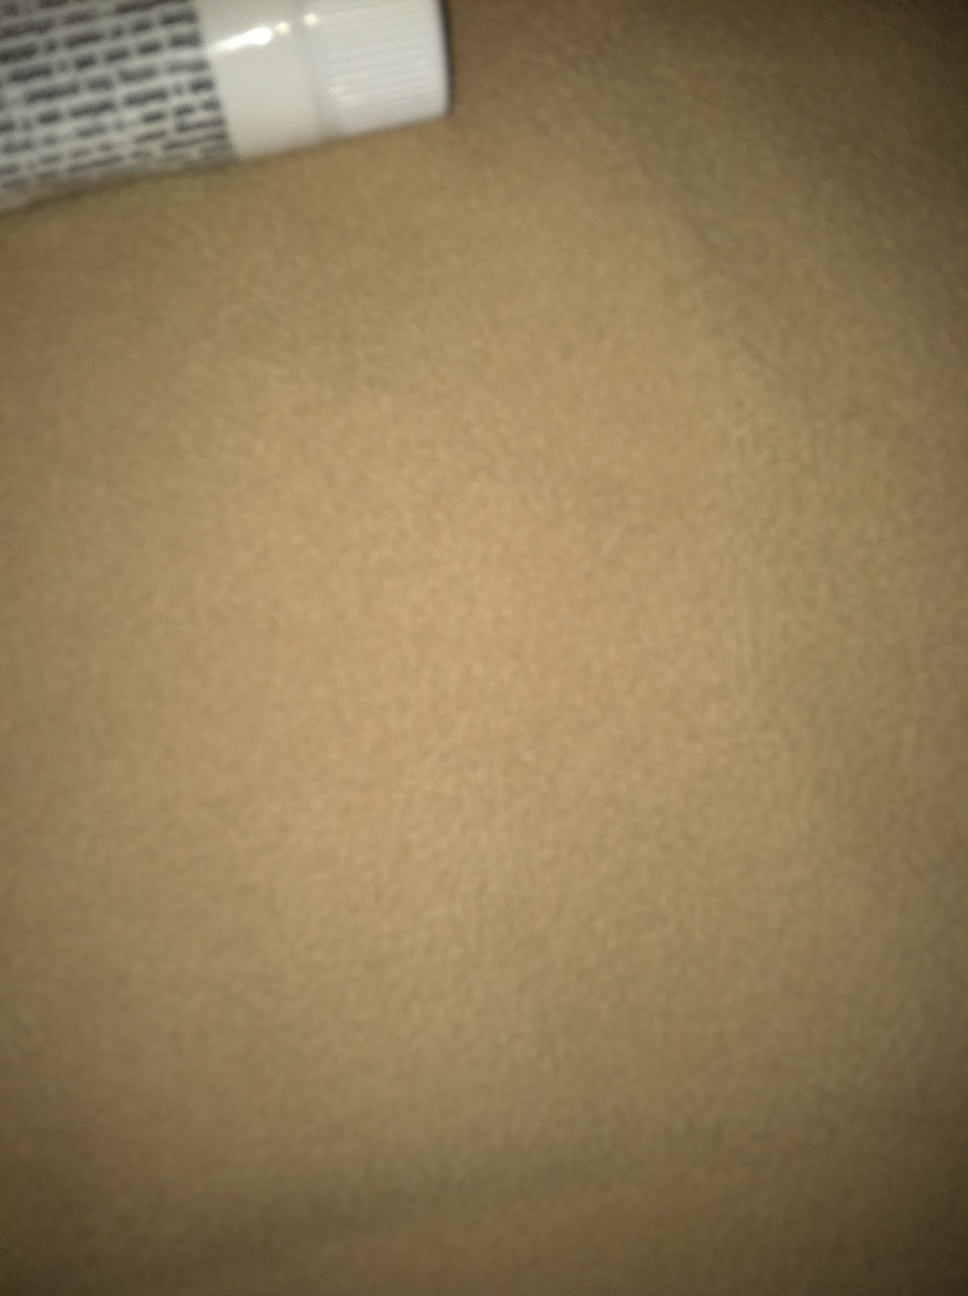What is this product? The image shows a partial view of a product, which appears to be the bottom edge of a tube, potentially a type of cream or ointment. Due to the limited view, I can't provide a specific product name, but it's typically used for skincare or medical purposes. 